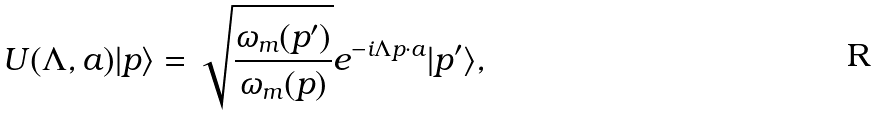Convert formula to latex. <formula><loc_0><loc_0><loc_500><loc_500>U ( \Lambda , a ) | p \rangle = \sqrt { \frac { \omega _ { m } ( p ^ { \prime } ) } { \omega _ { m } ( p ) } } e ^ { - i \Lambda p \cdot a } | p ^ { \prime } \rangle ,</formula> 